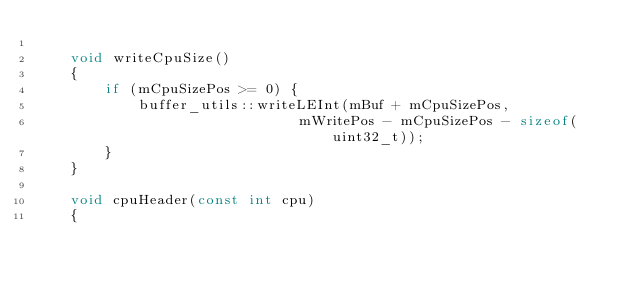Convert code to text. <code><loc_0><loc_0><loc_500><loc_500><_C++_>
    void writeCpuSize()
    {
        if (mCpuSizePos >= 0) {
            buffer_utils::writeLEInt(mBuf + mCpuSizePos,
                               mWritePos - mCpuSizePos - sizeof(uint32_t));
        }
    }

    void cpuHeader(const int cpu)
    {</code> 